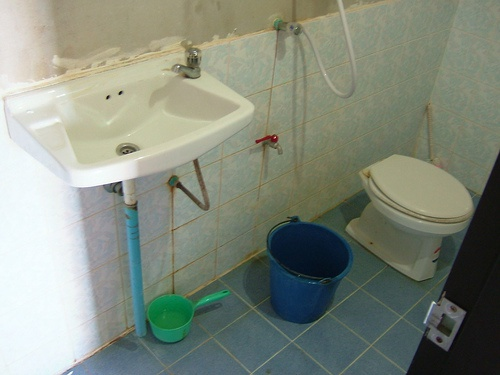Describe the objects in this image and their specific colors. I can see sink in lightgray, beige, darkgray, and tan tones and toilet in lightgray, gray, and darkgray tones in this image. 